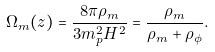Convert formula to latex. <formula><loc_0><loc_0><loc_500><loc_500>\Omega _ { m } ( z ) = \frac { 8 \pi \rho _ { m } } { 3 m _ { p } ^ { 2 } H ^ { 2 } } = \frac { \rho _ { m } } { \rho _ { m } + \rho _ { \phi } } .</formula> 